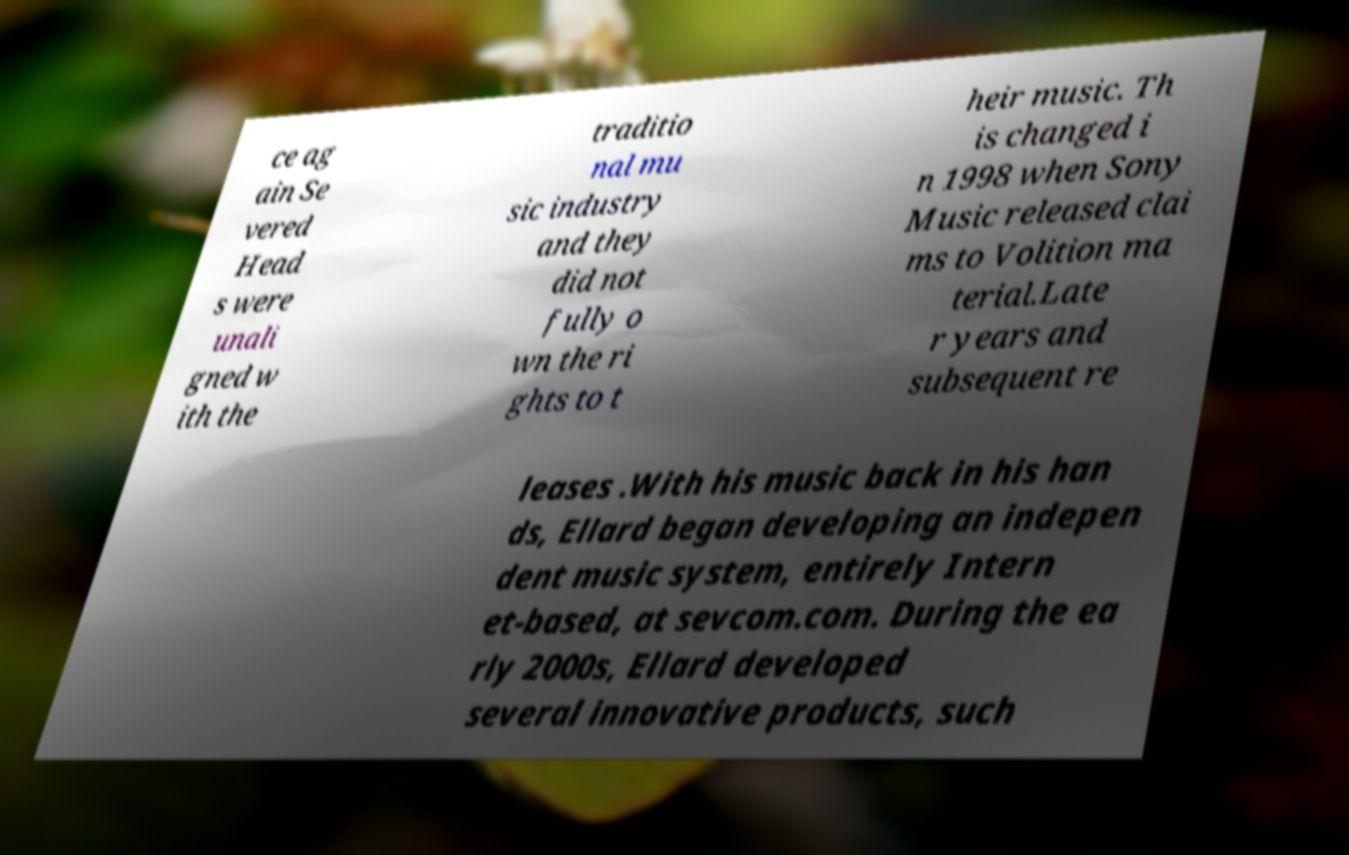Can you read and provide the text displayed in the image?This photo seems to have some interesting text. Can you extract and type it out for me? ce ag ain Se vered Head s were unali gned w ith the traditio nal mu sic industry and they did not fully o wn the ri ghts to t heir music. Th is changed i n 1998 when Sony Music released clai ms to Volition ma terial.Late r years and subsequent re leases .With his music back in his han ds, Ellard began developing an indepen dent music system, entirely Intern et-based, at sevcom.com. During the ea rly 2000s, Ellard developed several innovative products, such 